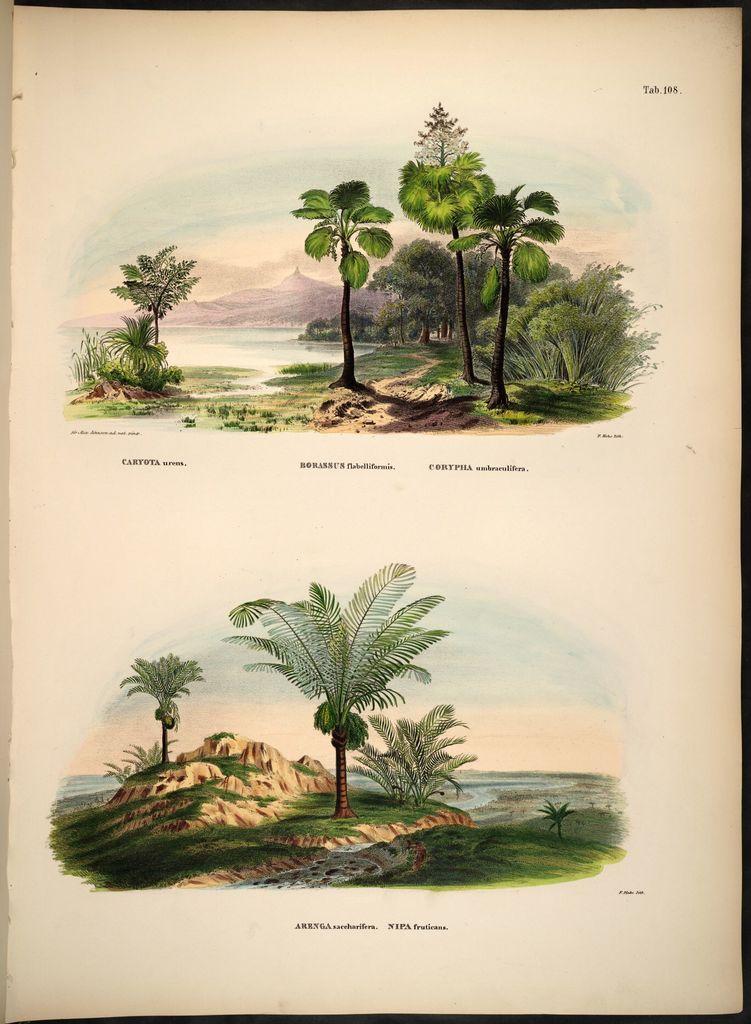Please provide a concise description of this image. This is a page. In this there are paintings of trees, river, plants and grasses. There are two painting on this page and something is written on the page. 